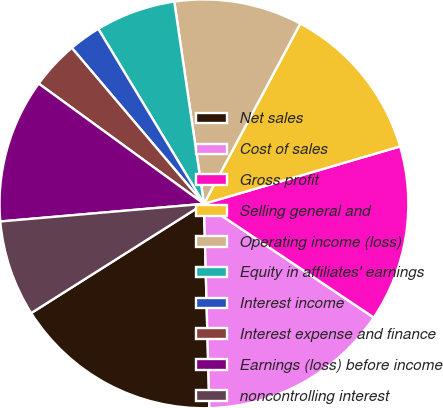<chart> <loc_0><loc_0><loc_500><loc_500><pie_chart><fcel>Net sales<fcel>Cost of sales<fcel>Gross profit<fcel>Selling general and<fcel>Operating income (loss)<fcel>Equity in affiliates' earnings<fcel>Interest income<fcel>Interest expense and finance<fcel>Earnings (loss) before income<fcel>noncontrolling interest<nl><fcel>16.45%<fcel>15.19%<fcel>13.92%<fcel>12.66%<fcel>10.13%<fcel>6.33%<fcel>2.54%<fcel>3.8%<fcel>11.39%<fcel>7.6%<nl></chart> 